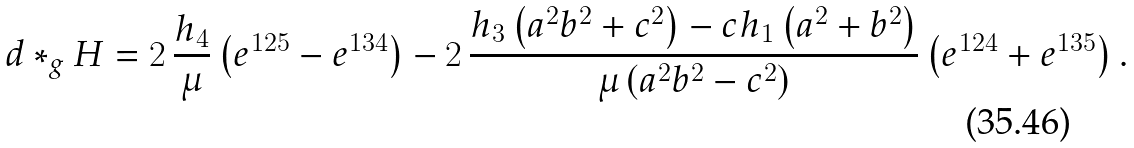Convert formula to latex. <formula><loc_0><loc_0><loc_500><loc_500>d * _ { g } H = 2 \, \frac { h _ { 4 } } { \mu } \left ( e ^ { 1 2 5 } - e ^ { 1 3 4 } \right ) - 2 \, \frac { h _ { 3 } \left ( a ^ { 2 } b ^ { 2 } + c ^ { 2 } \right ) - c h _ { 1 } \left ( a ^ { 2 } + b ^ { 2 } \right ) } { \mu \left ( a ^ { 2 } b ^ { 2 } - c ^ { 2 } \right ) } \left ( e ^ { 1 2 4 } + e ^ { 1 3 5 } \right ) .</formula> 